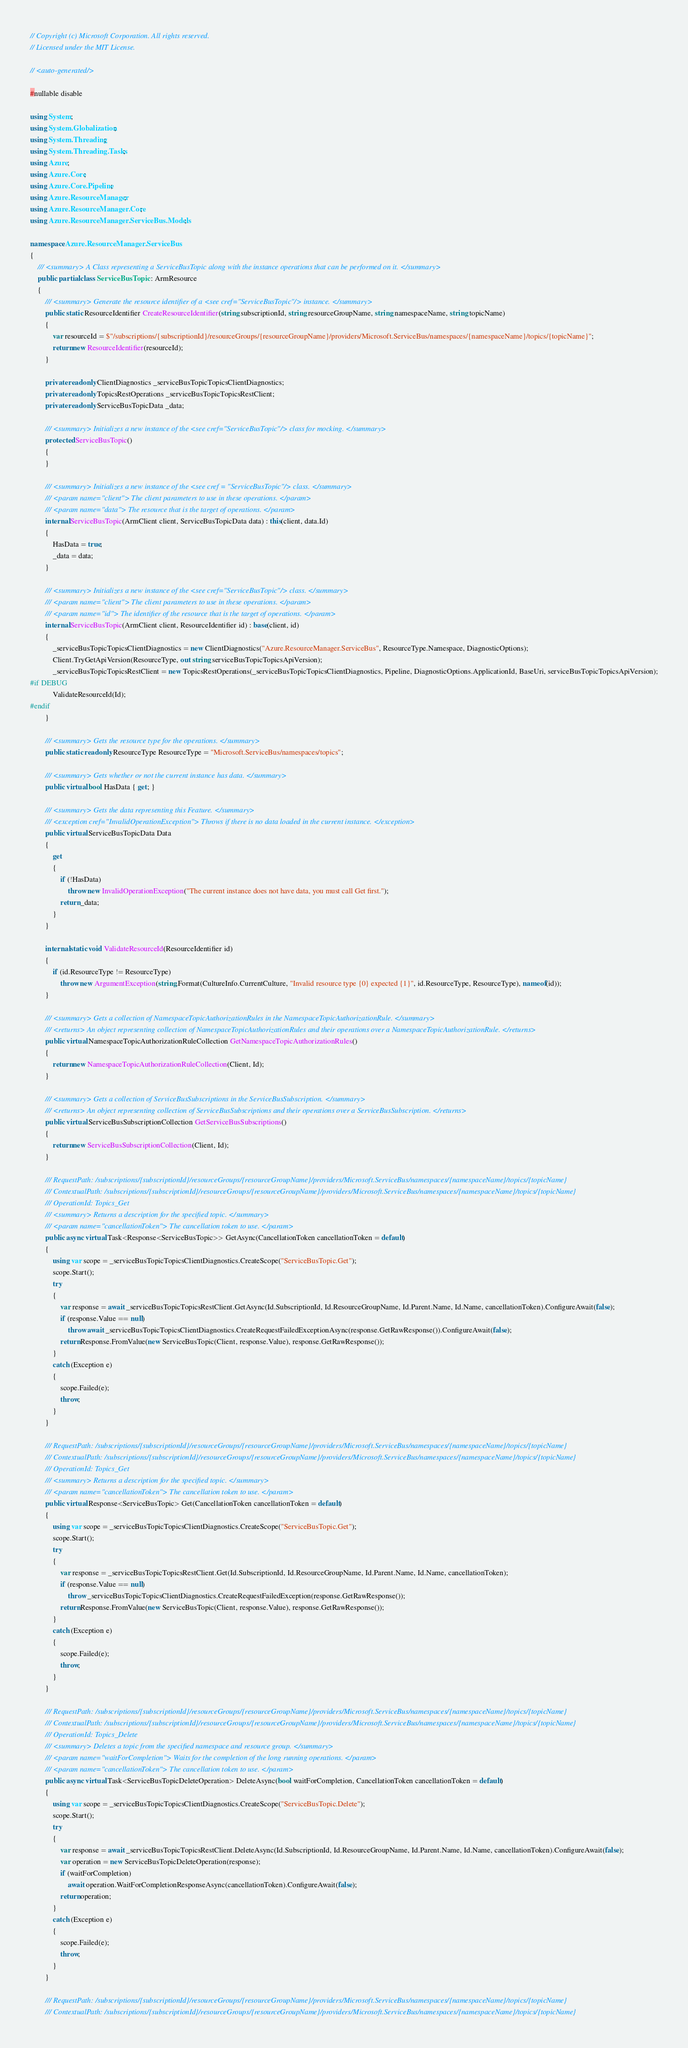Convert code to text. <code><loc_0><loc_0><loc_500><loc_500><_C#_>// Copyright (c) Microsoft Corporation. All rights reserved.
// Licensed under the MIT License.

// <auto-generated/>

#nullable disable

using System;
using System.Globalization;
using System.Threading;
using System.Threading.Tasks;
using Azure;
using Azure.Core;
using Azure.Core.Pipeline;
using Azure.ResourceManager;
using Azure.ResourceManager.Core;
using Azure.ResourceManager.ServiceBus.Models;

namespace Azure.ResourceManager.ServiceBus
{
    /// <summary> A Class representing a ServiceBusTopic along with the instance operations that can be performed on it. </summary>
    public partial class ServiceBusTopic : ArmResource
    {
        /// <summary> Generate the resource identifier of a <see cref="ServiceBusTopic"/> instance. </summary>
        public static ResourceIdentifier CreateResourceIdentifier(string subscriptionId, string resourceGroupName, string namespaceName, string topicName)
        {
            var resourceId = $"/subscriptions/{subscriptionId}/resourceGroups/{resourceGroupName}/providers/Microsoft.ServiceBus/namespaces/{namespaceName}/topics/{topicName}";
            return new ResourceIdentifier(resourceId);
        }

        private readonly ClientDiagnostics _serviceBusTopicTopicsClientDiagnostics;
        private readonly TopicsRestOperations _serviceBusTopicTopicsRestClient;
        private readonly ServiceBusTopicData _data;

        /// <summary> Initializes a new instance of the <see cref="ServiceBusTopic"/> class for mocking. </summary>
        protected ServiceBusTopic()
        {
        }

        /// <summary> Initializes a new instance of the <see cref = "ServiceBusTopic"/> class. </summary>
        /// <param name="client"> The client parameters to use in these operations. </param>
        /// <param name="data"> The resource that is the target of operations. </param>
        internal ServiceBusTopic(ArmClient client, ServiceBusTopicData data) : this(client, data.Id)
        {
            HasData = true;
            _data = data;
        }

        /// <summary> Initializes a new instance of the <see cref="ServiceBusTopic"/> class. </summary>
        /// <param name="client"> The client parameters to use in these operations. </param>
        /// <param name="id"> The identifier of the resource that is the target of operations. </param>
        internal ServiceBusTopic(ArmClient client, ResourceIdentifier id) : base(client, id)
        {
            _serviceBusTopicTopicsClientDiagnostics = new ClientDiagnostics("Azure.ResourceManager.ServiceBus", ResourceType.Namespace, DiagnosticOptions);
            Client.TryGetApiVersion(ResourceType, out string serviceBusTopicTopicsApiVersion);
            _serviceBusTopicTopicsRestClient = new TopicsRestOperations(_serviceBusTopicTopicsClientDiagnostics, Pipeline, DiagnosticOptions.ApplicationId, BaseUri, serviceBusTopicTopicsApiVersion);
#if DEBUG
			ValidateResourceId(Id);
#endif
        }

        /// <summary> Gets the resource type for the operations. </summary>
        public static readonly ResourceType ResourceType = "Microsoft.ServiceBus/namespaces/topics";

        /// <summary> Gets whether or not the current instance has data. </summary>
        public virtual bool HasData { get; }

        /// <summary> Gets the data representing this Feature. </summary>
        /// <exception cref="InvalidOperationException"> Throws if there is no data loaded in the current instance. </exception>
        public virtual ServiceBusTopicData Data
        {
            get
            {
                if (!HasData)
                    throw new InvalidOperationException("The current instance does not have data, you must call Get first.");
                return _data;
            }
        }

        internal static void ValidateResourceId(ResourceIdentifier id)
        {
            if (id.ResourceType != ResourceType)
                throw new ArgumentException(string.Format(CultureInfo.CurrentCulture, "Invalid resource type {0} expected {1}", id.ResourceType, ResourceType), nameof(id));
        }

        /// <summary> Gets a collection of NamespaceTopicAuthorizationRules in the NamespaceTopicAuthorizationRule. </summary>
        /// <returns> An object representing collection of NamespaceTopicAuthorizationRules and their operations over a NamespaceTopicAuthorizationRule. </returns>
        public virtual NamespaceTopicAuthorizationRuleCollection GetNamespaceTopicAuthorizationRules()
        {
            return new NamespaceTopicAuthorizationRuleCollection(Client, Id);
        }

        /// <summary> Gets a collection of ServiceBusSubscriptions in the ServiceBusSubscription. </summary>
        /// <returns> An object representing collection of ServiceBusSubscriptions and their operations over a ServiceBusSubscription. </returns>
        public virtual ServiceBusSubscriptionCollection GetServiceBusSubscriptions()
        {
            return new ServiceBusSubscriptionCollection(Client, Id);
        }

        /// RequestPath: /subscriptions/{subscriptionId}/resourceGroups/{resourceGroupName}/providers/Microsoft.ServiceBus/namespaces/{namespaceName}/topics/{topicName}
        /// ContextualPath: /subscriptions/{subscriptionId}/resourceGroups/{resourceGroupName}/providers/Microsoft.ServiceBus/namespaces/{namespaceName}/topics/{topicName}
        /// OperationId: Topics_Get
        /// <summary> Returns a description for the specified topic. </summary>
        /// <param name="cancellationToken"> The cancellation token to use. </param>
        public async virtual Task<Response<ServiceBusTopic>> GetAsync(CancellationToken cancellationToken = default)
        {
            using var scope = _serviceBusTopicTopicsClientDiagnostics.CreateScope("ServiceBusTopic.Get");
            scope.Start();
            try
            {
                var response = await _serviceBusTopicTopicsRestClient.GetAsync(Id.SubscriptionId, Id.ResourceGroupName, Id.Parent.Name, Id.Name, cancellationToken).ConfigureAwait(false);
                if (response.Value == null)
                    throw await _serviceBusTopicTopicsClientDiagnostics.CreateRequestFailedExceptionAsync(response.GetRawResponse()).ConfigureAwait(false);
                return Response.FromValue(new ServiceBusTopic(Client, response.Value), response.GetRawResponse());
            }
            catch (Exception e)
            {
                scope.Failed(e);
                throw;
            }
        }

        /// RequestPath: /subscriptions/{subscriptionId}/resourceGroups/{resourceGroupName}/providers/Microsoft.ServiceBus/namespaces/{namespaceName}/topics/{topicName}
        /// ContextualPath: /subscriptions/{subscriptionId}/resourceGroups/{resourceGroupName}/providers/Microsoft.ServiceBus/namespaces/{namespaceName}/topics/{topicName}
        /// OperationId: Topics_Get
        /// <summary> Returns a description for the specified topic. </summary>
        /// <param name="cancellationToken"> The cancellation token to use. </param>
        public virtual Response<ServiceBusTopic> Get(CancellationToken cancellationToken = default)
        {
            using var scope = _serviceBusTopicTopicsClientDiagnostics.CreateScope("ServiceBusTopic.Get");
            scope.Start();
            try
            {
                var response = _serviceBusTopicTopicsRestClient.Get(Id.SubscriptionId, Id.ResourceGroupName, Id.Parent.Name, Id.Name, cancellationToken);
                if (response.Value == null)
                    throw _serviceBusTopicTopicsClientDiagnostics.CreateRequestFailedException(response.GetRawResponse());
                return Response.FromValue(new ServiceBusTopic(Client, response.Value), response.GetRawResponse());
            }
            catch (Exception e)
            {
                scope.Failed(e);
                throw;
            }
        }

        /// RequestPath: /subscriptions/{subscriptionId}/resourceGroups/{resourceGroupName}/providers/Microsoft.ServiceBus/namespaces/{namespaceName}/topics/{topicName}
        /// ContextualPath: /subscriptions/{subscriptionId}/resourceGroups/{resourceGroupName}/providers/Microsoft.ServiceBus/namespaces/{namespaceName}/topics/{topicName}
        /// OperationId: Topics_Delete
        /// <summary> Deletes a topic from the specified namespace and resource group. </summary>
        /// <param name="waitForCompletion"> Waits for the completion of the long running operations. </param>
        /// <param name="cancellationToken"> The cancellation token to use. </param>
        public async virtual Task<ServiceBusTopicDeleteOperation> DeleteAsync(bool waitForCompletion, CancellationToken cancellationToken = default)
        {
            using var scope = _serviceBusTopicTopicsClientDiagnostics.CreateScope("ServiceBusTopic.Delete");
            scope.Start();
            try
            {
                var response = await _serviceBusTopicTopicsRestClient.DeleteAsync(Id.SubscriptionId, Id.ResourceGroupName, Id.Parent.Name, Id.Name, cancellationToken).ConfigureAwait(false);
                var operation = new ServiceBusTopicDeleteOperation(response);
                if (waitForCompletion)
                    await operation.WaitForCompletionResponseAsync(cancellationToken).ConfigureAwait(false);
                return operation;
            }
            catch (Exception e)
            {
                scope.Failed(e);
                throw;
            }
        }

        /// RequestPath: /subscriptions/{subscriptionId}/resourceGroups/{resourceGroupName}/providers/Microsoft.ServiceBus/namespaces/{namespaceName}/topics/{topicName}
        /// ContextualPath: /subscriptions/{subscriptionId}/resourceGroups/{resourceGroupName}/providers/Microsoft.ServiceBus/namespaces/{namespaceName}/topics/{topicName}</code> 